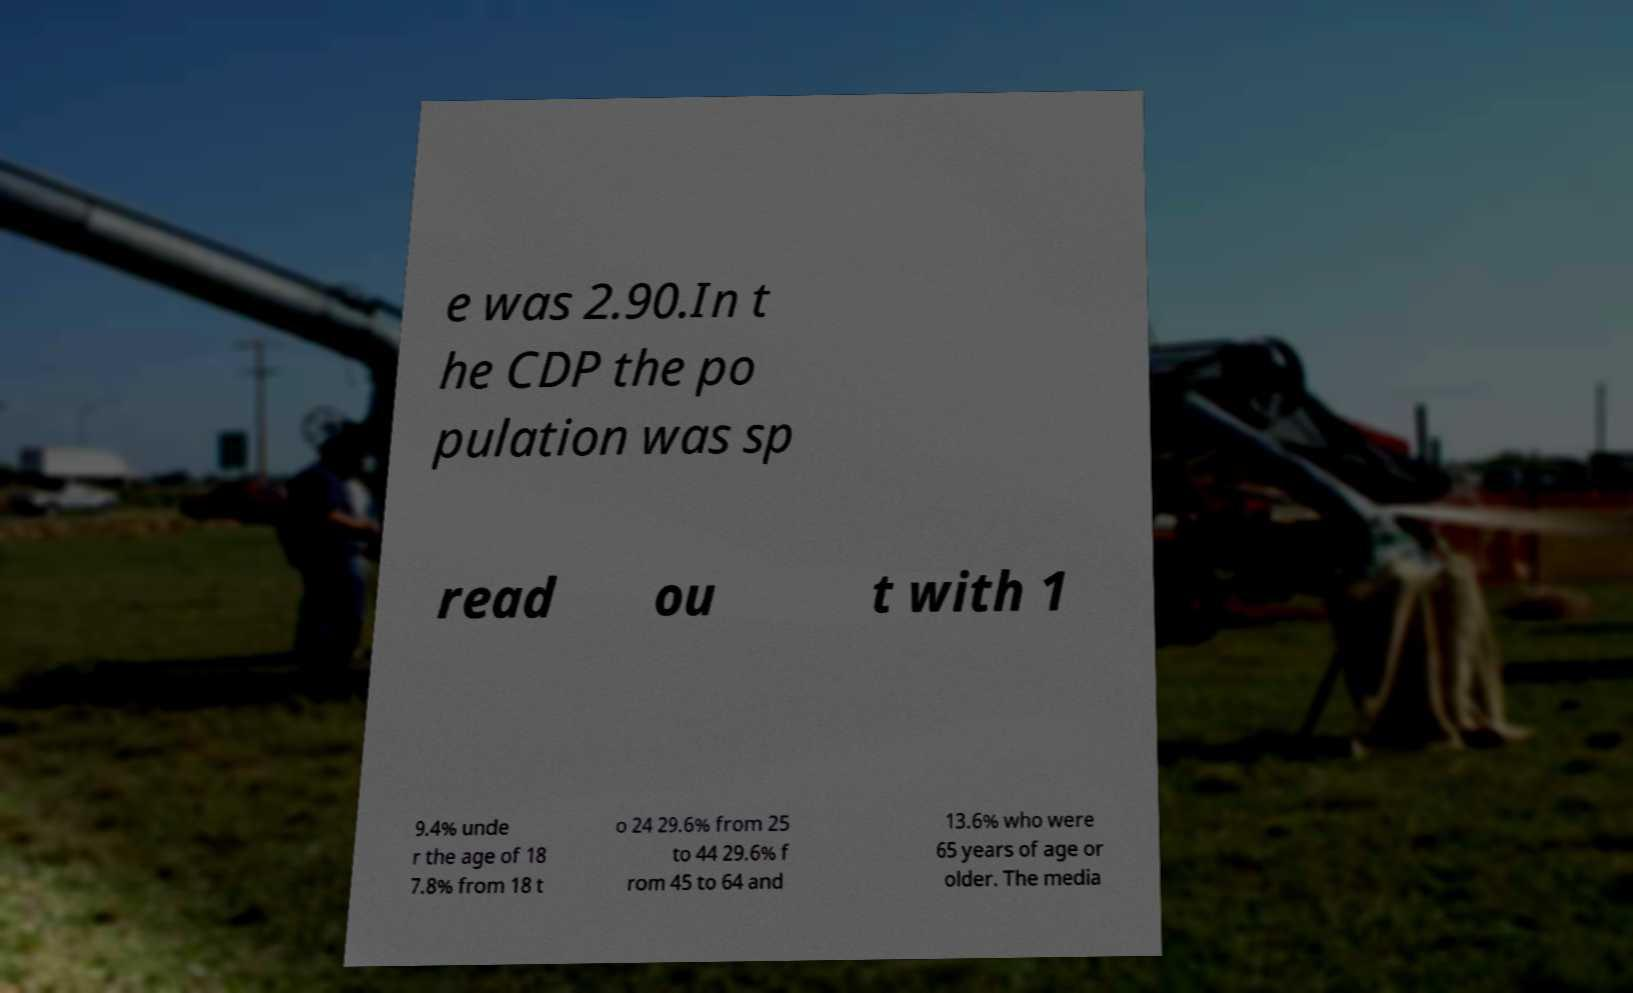Please identify and transcribe the text found in this image. e was 2.90.In t he CDP the po pulation was sp read ou t with 1 9.4% unde r the age of 18 7.8% from 18 t o 24 29.6% from 25 to 44 29.6% f rom 45 to 64 and 13.6% who were 65 years of age or older. The media 